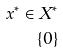Convert formula to latex. <formula><loc_0><loc_0><loc_500><loc_500>x ^ { * } \in X ^ { * } \\ \{ 0 \}</formula> 